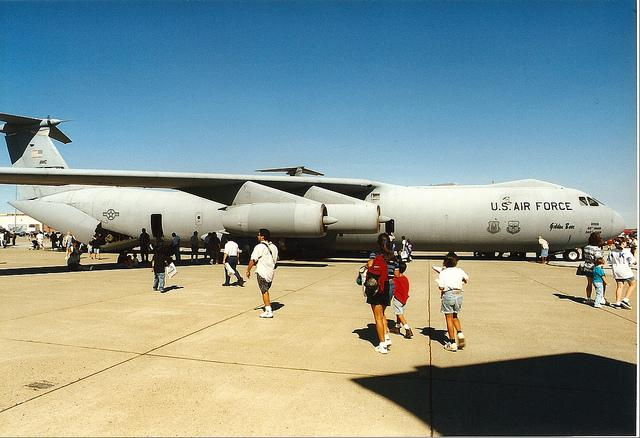What type of military individual fly's this plane? Please explain your reasoning. airmen. The airmen would fly the plane. 